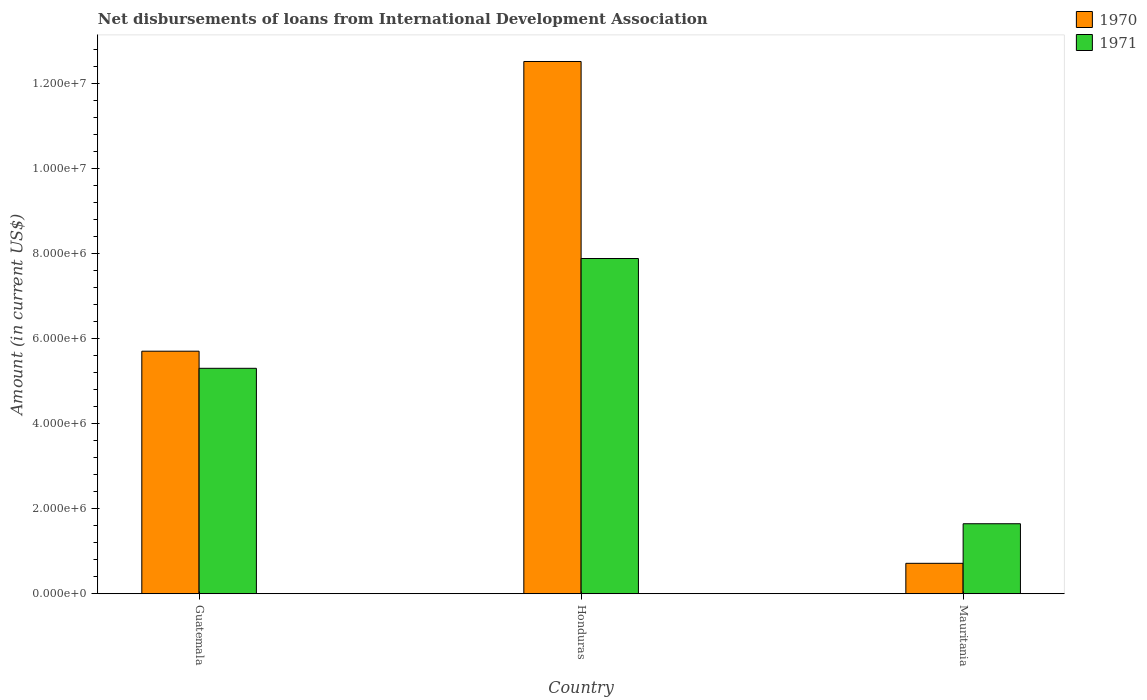How many different coloured bars are there?
Give a very brief answer. 2. How many groups of bars are there?
Offer a terse response. 3. Are the number of bars per tick equal to the number of legend labels?
Your answer should be compact. Yes. Are the number of bars on each tick of the X-axis equal?
Ensure brevity in your answer.  Yes. What is the label of the 2nd group of bars from the left?
Make the answer very short. Honduras. What is the amount of loans disbursed in 1970 in Guatemala?
Provide a short and direct response. 5.70e+06. Across all countries, what is the maximum amount of loans disbursed in 1970?
Offer a terse response. 1.25e+07. Across all countries, what is the minimum amount of loans disbursed in 1971?
Provide a short and direct response. 1.64e+06. In which country was the amount of loans disbursed in 1970 maximum?
Provide a succinct answer. Honduras. In which country was the amount of loans disbursed in 1970 minimum?
Make the answer very short. Mauritania. What is the total amount of loans disbursed in 1970 in the graph?
Your answer should be very brief. 1.89e+07. What is the difference between the amount of loans disbursed in 1971 in Guatemala and that in Mauritania?
Your answer should be compact. 3.65e+06. What is the difference between the amount of loans disbursed in 1971 in Mauritania and the amount of loans disbursed in 1970 in Honduras?
Offer a very short reply. -1.09e+07. What is the average amount of loans disbursed in 1971 per country?
Make the answer very short. 4.94e+06. What is the difference between the amount of loans disbursed of/in 1971 and amount of loans disbursed of/in 1970 in Mauritania?
Your response must be concise. 9.30e+05. What is the ratio of the amount of loans disbursed in 1970 in Guatemala to that in Mauritania?
Give a very brief answer. 7.97. Is the amount of loans disbursed in 1970 in Guatemala less than that in Mauritania?
Make the answer very short. No. Is the difference between the amount of loans disbursed in 1971 in Guatemala and Mauritania greater than the difference between the amount of loans disbursed in 1970 in Guatemala and Mauritania?
Your answer should be compact. No. What is the difference between the highest and the second highest amount of loans disbursed in 1971?
Keep it short and to the point. 2.58e+06. What is the difference between the highest and the lowest amount of loans disbursed in 1970?
Provide a short and direct response. 1.18e+07. What does the 1st bar from the left in Mauritania represents?
Provide a succinct answer. 1970. How many bars are there?
Your answer should be very brief. 6. Are all the bars in the graph horizontal?
Make the answer very short. No. Where does the legend appear in the graph?
Keep it short and to the point. Top right. How are the legend labels stacked?
Make the answer very short. Vertical. What is the title of the graph?
Offer a very short reply. Net disbursements of loans from International Development Association. Does "1991" appear as one of the legend labels in the graph?
Make the answer very short. No. What is the label or title of the X-axis?
Your answer should be very brief. Country. What is the Amount (in current US$) of 1970 in Guatemala?
Provide a short and direct response. 5.70e+06. What is the Amount (in current US$) of 1971 in Guatemala?
Offer a terse response. 5.30e+06. What is the Amount (in current US$) in 1970 in Honduras?
Your answer should be compact. 1.25e+07. What is the Amount (in current US$) of 1971 in Honduras?
Offer a very short reply. 7.88e+06. What is the Amount (in current US$) in 1970 in Mauritania?
Your response must be concise. 7.15e+05. What is the Amount (in current US$) of 1971 in Mauritania?
Keep it short and to the point. 1.64e+06. Across all countries, what is the maximum Amount (in current US$) of 1970?
Your answer should be very brief. 1.25e+07. Across all countries, what is the maximum Amount (in current US$) in 1971?
Offer a terse response. 7.88e+06. Across all countries, what is the minimum Amount (in current US$) of 1970?
Ensure brevity in your answer.  7.15e+05. Across all countries, what is the minimum Amount (in current US$) in 1971?
Give a very brief answer. 1.64e+06. What is the total Amount (in current US$) of 1970 in the graph?
Ensure brevity in your answer.  1.89e+07. What is the total Amount (in current US$) of 1971 in the graph?
Your answer should be compact. 1.48e+07. What is the difference between the Amount (in current US$) in 1970 in Guatemala and that in Honduras?
Your response must be concise. -6.81e+06. What is the difference between the Amount (in current US$) of 1971 in Guatemala and that in Honduras?
Ensure brevity in your answer.  -2.58e+06. What is the difference between the Amount (in current US$) of 1970 in Guatemala and that in Mauritania?
Offer a terse response. 4.98e+06. What is the difference between the Amount (in current US$) in 1971 in Guatemala and that in Mauritania?
Your answer should be compact. 3.65e+06. What is the difference between the Amount (in current US$) of 1970 in Honduras and that in Mauritania?
Your answer should be very brief. 1.18e+07. What is the difference between the Amount (in current US$) in 1971 in Honduras and that in Mauritania?
Your response must be concise. 6.23e+06. What is the difference between the Amount (in current US$) in 1970 in Guatemala and the Amount (in current US$) in 1971 in Honduras?
Offer a very short reply. -2.18e+06. What is the difference between the Amount (in current US$) of 1970 in Guatemala and the Amount (in current US$) of 1971 in Mauritania?
Offer a terse response. 4.06e+06. What is the difference between the Amount (in current US$) of 1970 in Honduras and the Amount (in current US$) of 1971 in Mauritania?
Offer a very short reply. 1.09e+07. What is the average Amount (in current US$) of 1970 per country?
Ensure brevity in your answer.  6.31e+06. What is the average Amount (in current US$) in 1971 per country?
Offer a terse response. 4.94e+06. What is the difference between the Amount (in current US$) in 1970 and Amount (in current US$) in 1971 in Guatemala?
Keep it short and to the point. 4.02e+05. What is the difference between the Amount (in current US$) of 1970 and Amount (in current US$) of 1971 in Honduras?
Keep it short and to the point. 4.63e+06. What is the difference between the Amount (in current US$) of 1970 and Amount (in current US$) of 1971 in Mauritania?
Offer a terse response. -9.30e+05. What is the ratio of the Amount (in current US$) of 1970 in Guatemala to that in Honduras?
Your answer should be compact. 0.46. What is the ratio of the Amount (in current US$) in 1971 in Guatemala to that in Honduras?
Offer a terse response. 0.67. What is the ratio of the Amount (in current US$) of 1970 in Guatemala to that in Mauritania?
Your answer should be very brief. 7.97. What is the ratio of the Amount (in current US$) of 1971 in Guatemala to that in Mauritania?
Offer a terse response. 3.22. What is the ratio of the Amount (in current US$) in 1970 in Honduras to that in Mauritania?
Provide a short and direct response. 17.49. What is the ratio of the Amount (in current US$) of 1971 in Honduras to that in Mauritania?
Your answer should be compact. 4.79. What is the difference between the highest and the second highest Amount (in current US$) in 1970?
Make the answer very short. 6.81e+06. What is the difference between the highest and the second highest Amount (in current US$) of 1971?
Provide a short and direct response. 2.58e+06. What is the difference between the highest and the lowest Amount (in current US$) of 1970?
Make the answer very short. 1.18e+07. What is the difference between the highest and the lowest Amount (in current US$) in 1971?
Offer a very short reply. 6.23e+06. 